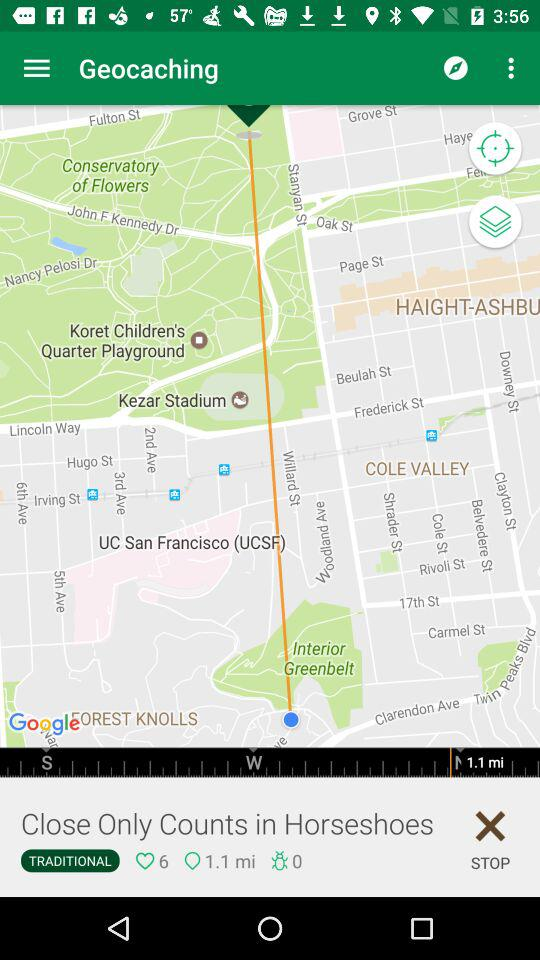What is the application name? The application name is "Geocaching". 